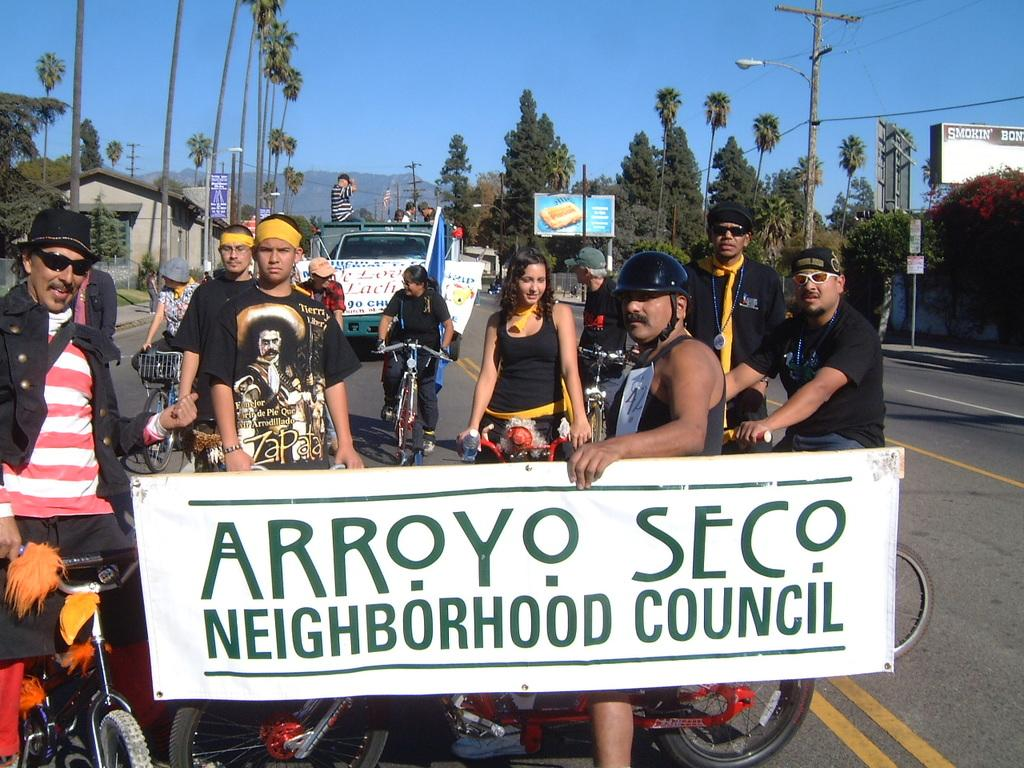What is happening on the road in the image? There are many people standing on the road. What else can be seen on the road? There are vehicles present. What type of natural elements are visible in the image? There are many trees visible. What is the condition of the sky in the image? The sky is clear. What color is the sneeze coming out of the person's nose in the image? There is no sneeze present in the image, and therefore no color can be determined. How many houses are visible in the image? There is no mention of houses in the provided facts, so we cannot determine the number of houses in the image. 